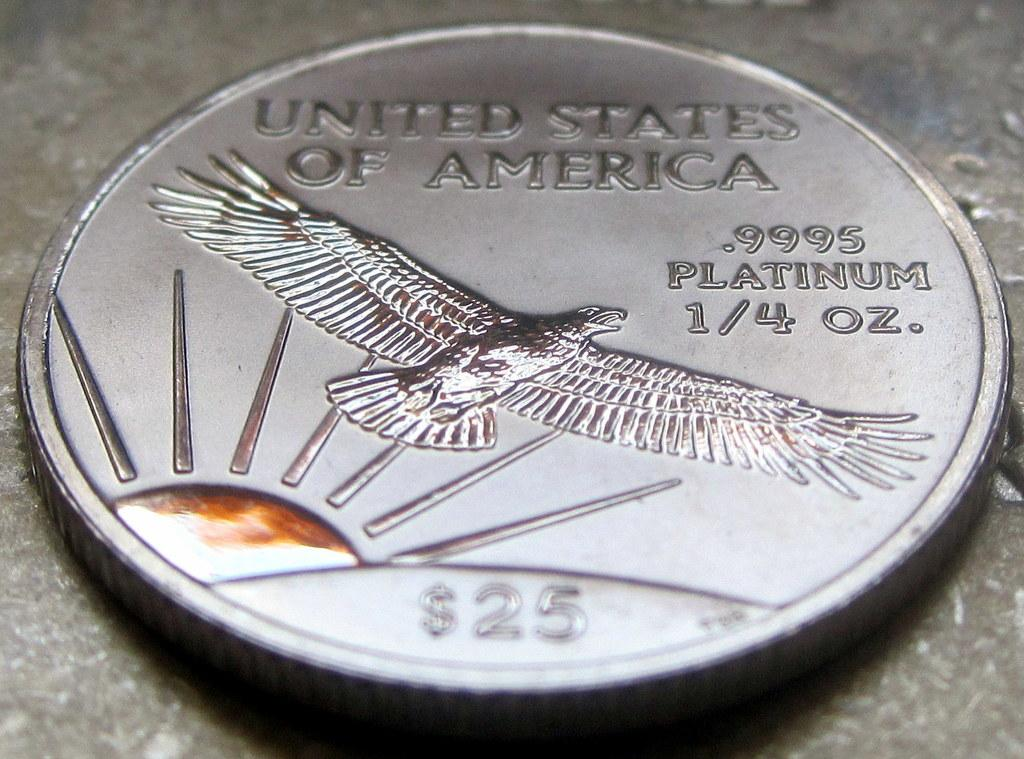What is the main object in the image? There is a currency coin in the image. What can be found on the surface of the coin? The coin has text on it and features an image of the sun and an eagle. What is the color of the surface on which the coin is placed? The coin is placed on a black surface. What type of bag can be seen hanging from the eagle's beak in the image? There is no bag present in the image, and the eagle's beak is not depicted. 